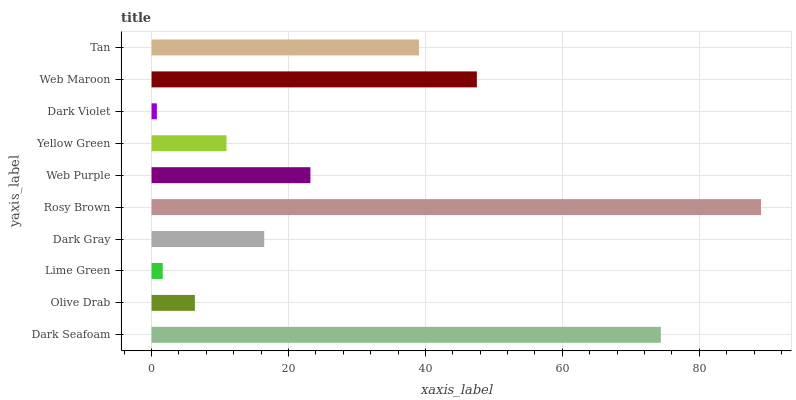Is Dark Violet the minimum?
Answer yes or no. Yes. Is Rosy Brown the maximum?
Answer yes or no. Yes. Is Olive Drab the minimum?
Answer yes or no. No. Is Olive Drab the maximum?
Answer yes or no. No. Is Dark Seafoam greater than Olive Drab?
Answer yes or no. Yes. Is Olive Drab less than Dark Seafoam?
Answer yes or no. Yes. Is Olive Drab greater than Dark Seafoam?
Answer yes or no. No. Is Dark Seafoam less than Olive Drab?
Answer yes or no. No. Is Web Purple the high median?
Answer yes or no. Yes. Is Dark Gray the low median?
Answer yes or no. Yes. Is Dark Violet the high median?
Answer yes or no. No. Is Tan the low median?
Answer yes or no. No. 